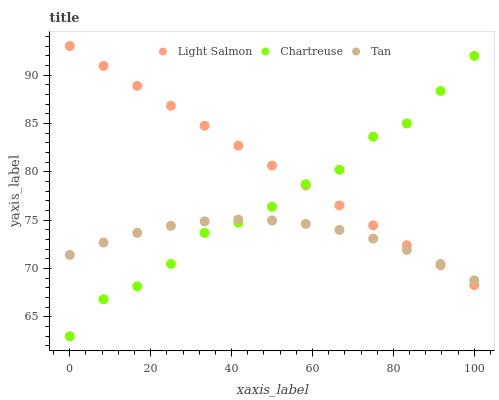Does Tan have the minimum area under the curve?
Answer yes or no. Yes. Does Light Salmon have the maximum area under the curve?
Answer yes or no. Yes. Does Chartreuse have the minimum area under the curve?
Answer yes or no. No. Does Chartreuse have the maximum area under the curve?
Answer yes or no. No. Is Light Salmon the smoothest?
Answer yes or no. Yes. Is Chartreuse the roughest?
Answer yes or no. Yes. Is Tan the smoothest?
Answer yes or no. No. Is Tan the roughest?
Answer yes or no. No. Does Chartreuse have the lowest value?
Answer yes or no. Yes. Does Tan have the lowest value?
Answer yes or no. No. Does Light Salmon have the highest value?
Answer yes or no. Yes. Does Chartreuse have the highest value?
Answer yes or no. No. Does Chartreuse intersect Tan?
Answer yes or no. Yes. Is Chartreuse less than Tan?
Answer yes or no. No. Is Chartreuse greater than Tan?
Answer yes or no. No. 